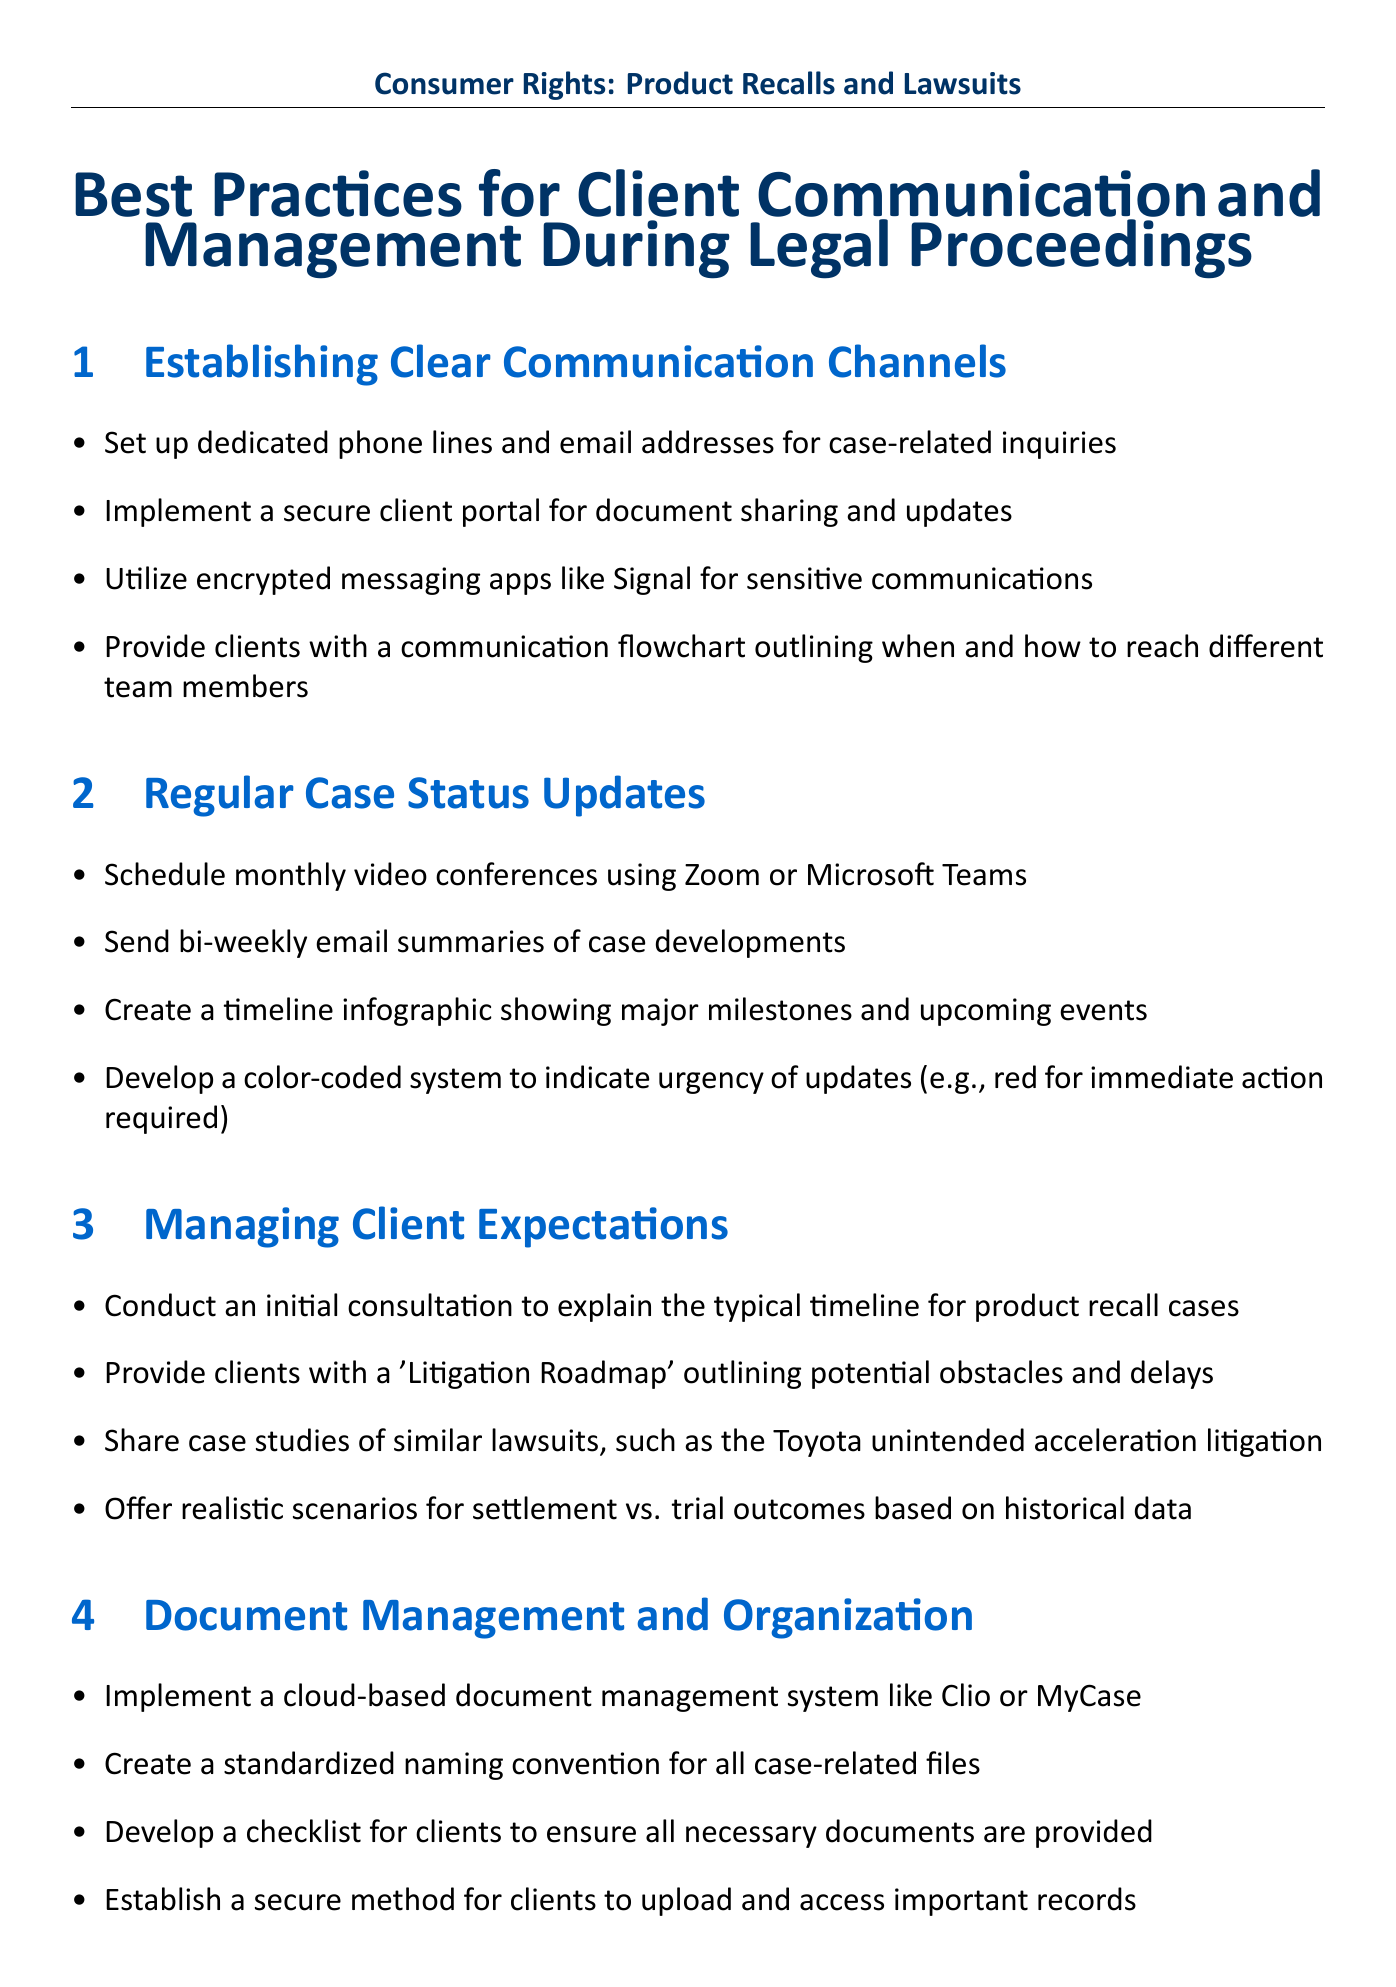what is included in the section on emotional support? The section includes resources for emotional support, such as maintaining a list of local support groups and partnering with mental health professionals.
Answer: local support groups, mental health professionals how often should clients receive case status updates? The document specifies a schedule for updates, indicating the frequency of updates.
Answer: bi-weekly what tool is suggested for secure document sharing? The manual recommends implementing a specific type of system for document management.
Answer: secure client portal what is a recommended method for managing client expectations? The document suggests conducting an initial consultation as a method for managing expectations.
Answer: initial consultation what type of meetings should be scheduled quarterly? The document specifies a type of meeting that focuses on strategy and collaboration with clients.
Answer: strategy meetings which apps are suggested for sensitive communications? The manual mentions specific applications that can be used for secure communication.
Answer: Signal what is recommended for preparing clients for media interactions? The document outlines a specific type of preparation for clients in media-related scenarios.
Answer: media training sessions how are email summaries of case developments described? The document mentions the frequency and purpose of these summaries in client communication.
Answer: bi-weekly email summaries what type of resources are provided for post-resolution support? The section outlines the kind of support offered after a case is resolved.
Answer: post-case counseling sessions 